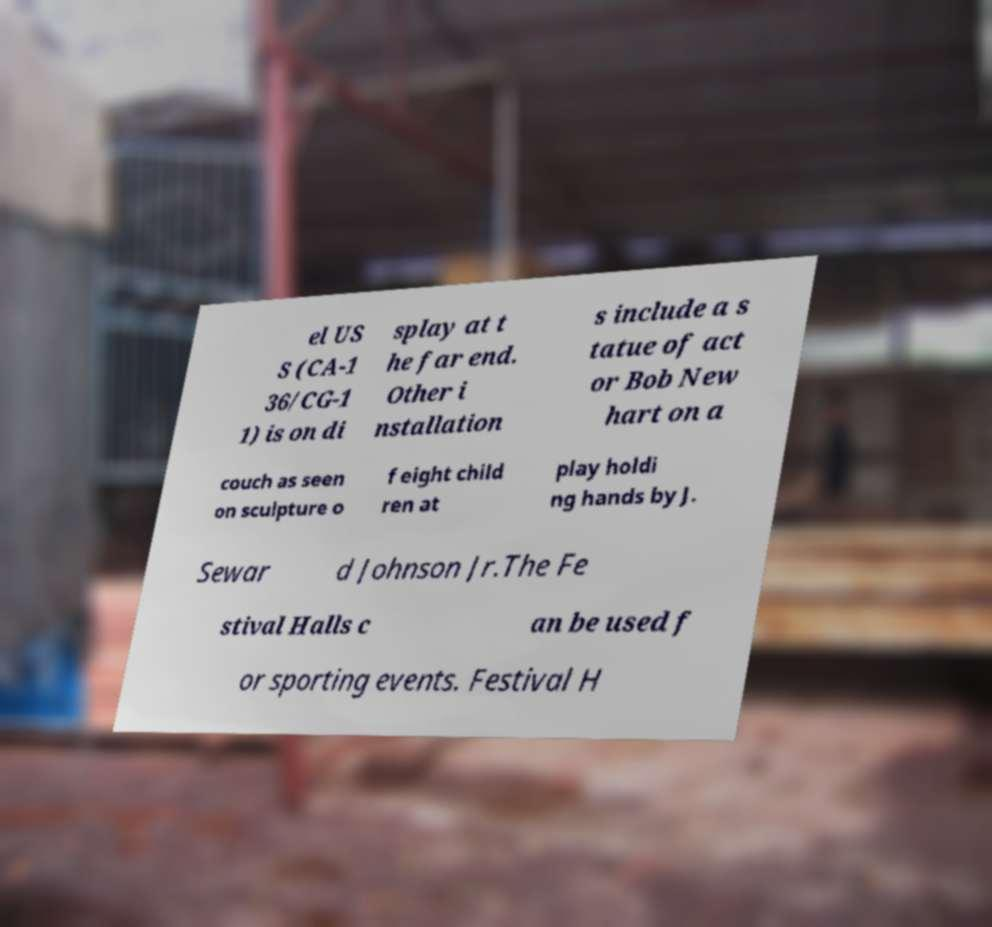Please identify and transcribe the text found in this image. el US S (CA-1 36/CG-1 1) is on di splay at t he far end. Other i nstallation s include a s tatue of act or Bob New hart on a couch as seen on sculpture o f eight child ren at play holdi ng hands by J. Sewar d Johnson Jr.The Fe stival Halls c an be used f or sporting events. Festival H 